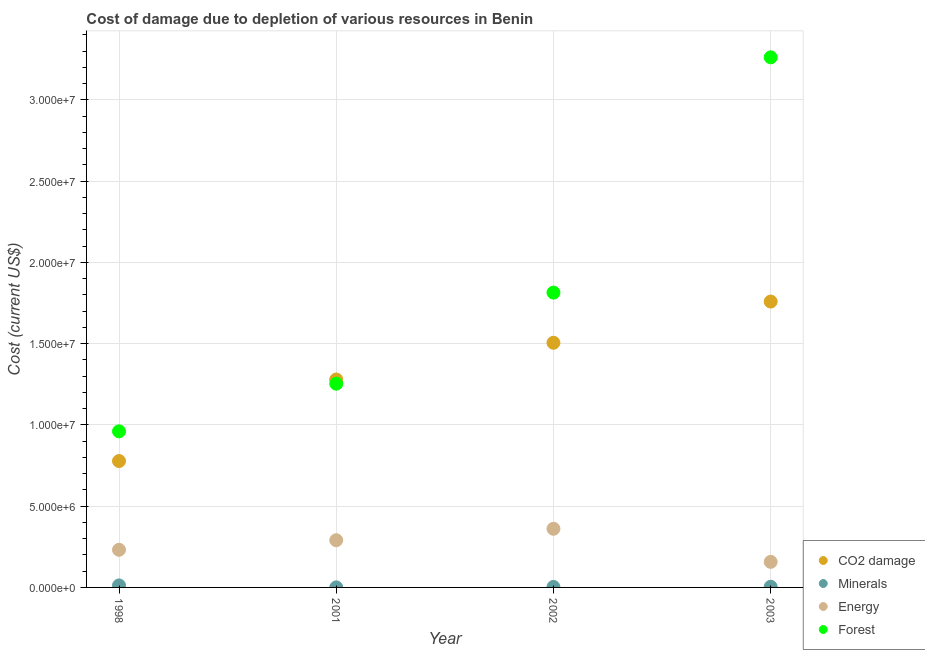How many different coloured dotlines are there?
Make the answer very short. 4. Is the number of dotlines equal to the number of legend labels?
Offer a terse response. Yes. What is the cost of damage due to depletion of forests in 2001?
Your response must be concise. 1.25e+07. Across all years, what is the maximum cost of damage due to depletion of minerals?
Provide a short and direct response. 1.23e+05. Across all years, what is the minimum cost of damage due to depletion of forests?
Provide a succinct answer. 9.60e+06. In which year was the cost of damage due to depletion of forests maximum?
Provide a succinct answer. 2003. What is the total cost of damage due to depletion of forests in the graph?
Your answer should be very brief. 7.29e+07. What is the difference between the cost of damage due to depletion of forests in 2001 and that in 2002?
Provide a short and direct response. -5.60e+06. What is the difference between the cost of damage due to depletion of energy in 2002 and the cost of damage due to depletion of forests in 1998?
Ensure brevity in your answer.  -5.99e+06. What is the average cost of damage due to depletion of energy per year?
Keep it short and to the point. 2.60e+06. In the year 2003, what is the difference between the cost of damage due to depletion of energy and cost of damage due to depletion of forests?
Offer a terse response. -3.10e+07. What is the ratio of the cost of damage due to depletion of energy in 1998 to that in 2001?
Your answer should be compact. 0.8. Is the cost of damage due to depletion of minerals in 2001 less than that in 2002?
Offer a terse response. Yes. Is the difference between the cost of damage due to depletion of minerals in 1998 and 2001 greater than the difference between the cost of damage due to depletion of coal in 1998 and 2001?
Ensure brevity in your answer.  Yes. What is the difference between the highest and the second highest cost of damage due to depletion of minerals?
Give a very brief answer. 8.37e+04. What is the difference between the highest and the lowest cost of damage due to depletion of forests?
Provide a short and direct response. 2.30e+07. In how many years, is the cost of damage due to depletion of minerals greater than the average cost of damage due to depletion of minerals taken over all years?
Your response must be concise. 1. Is the sum of the cost of damage due to depletion of forests in 2001 and 2003 greater than the maximum cost of damage due to depletion of energy across all years?
Offer a terse response. Yes. Is the cost of damage due to depletion of minerals strictly greater than the cost of damage due to depletion of forests over the years?
Give a very brief answer. No. How many dotlines are there?
Provide a short and direct response. 4. How many years are there in the graph?
Keep it short and to the point. 4. Are the values on the major ticks of Y-axis written in scientific E-notation?
Ensure brevity in your answer.  Yes. How many legend labels are there?
Keep it short and to the point. 4. What is the title of the graph?
Ensure brevity in your answer.  Cost of damage due to depletion of various resources in Benin . What is the label or title of the X-axis?
Keep it short and to the point. Year. What is the label or title of the Y-axis?
Offer a very short reply. Cost (current US$). What is the Cost (current US$) of CO2 damage in 1998?
Ensure brevity in your answer.  7.78e+06. What is the Cost (current US$) in Minerals in 1998?
Keep it short and to the point. 1.23e+05. What is the Cost (current US$) of Energy in 1998?
Make the answer very short. 2.32e+06. What is the Cost (current US$) in Forest in 1998?
Offer a very short reply. 9.60e+06. What is the Cost (current US$) in CO2 damage in 2001?
Give a very brief answer. 1.28e+07. What is the Cost (current US$) of Minerals in 2001?
Make the answer very short. 2027.69. What is the Cost (current US$) of Energy in 2001?
Provide a short and direct response. 2.90e+06. What is the Cost (current US$) in Forest in 2001?
Give a very brief answer. 1.25e+07. What is the Cost (current US$) of CO2 damage in 2002?
Offer a terse response. 1.51e+07. What is the Cost (current US$) of Minerals in 2002?
Give a very brief answer. 2.96e+04. What is the Cost (current US$) of Energy in 2002?
Offer a terse response. 3.61e+06. What is the Cost (current US$) of Forest in 2002?
Offer a very short reply. 1.81e+07. What is the Cost (current US$) in CO2 damage in 2003?
Keep it short and to the point. 1.76e+07. What is the Cost (current US$) in Minerals in 2003?
Your answer should be compact. 3.92e+04. What is the Cost (current US$) in Energy in 2003?
Your answer should be compact. 1.57e+06. What is the Cost (current US$) in Forest in 2003?
Offer a very short reply. 3.26e+07. Across all years, what is the maximum Cost (current US$) of CO2 damage?
Provide a succinct answer. 1.76e+07. Across all years, what is the maximum Cost (current US$) of Minerals?
Give a very brief answer. 1.23e+05. Across all years, what is the maximum Cost (current US$) in Energy?
Ensure brevity in your answer.  3.61e+06. Across all years, what is the maximum Cost (current US$) in Forest?
Provide a succinct answer. 3.26e+07. Across all years, what is the minimum Cost (current US$) of CO2 damage?
Ensure brevity in your answer.  7.78e+06. Across all years, what is the minimum Cost (current US$) of Minerals?
Your answer should be compact. 2027.69. Across all years, what is the minimum Cost (current US$) in Energy?
Your answer should be compact. 1.57e+06. Across all years, what is the minimum Cost (current US$) of Forest?
Provide a short and direct response. 9.60e+06. What is the total Cost (current US$) of CO2 damage in the graph?
Provide a succinct answer. 5.32e+07. What is the total Cost (current US$) of Minerals in the graph?
Your answer should be very brief. 1.94e+05. What is the total Cost (current US$) in Energy in the graph?
Keep it short and to the point. 1.04e+07. What is the total Cost (current US$) of Forest in the graph?
Offer a very short reply. 7.29e+07. What is the difference between the Cost (current US$) in CO2 damage in 1998 and that in 2001?
Your answer should be compact. -5.02e+06. What is the difference between the Cost (current US$) in Minerals in 1998 and that in 2001?
Keep it short and to the point. 1.21e+05. What is the difference between the Cost (current US$) of Energy in 1998 and that in 2001?
Provide a short and direct response. -5.87e+05. What is the difference between the Cost (current US$) of Forest in 1998 and that in 2001?
Ensure brevity in your answer.  -2.93e+06. What is the difference between the Cost (current US$) in CO2 damage in 1998 and that in 2002?
Keep it short and to the point. -7.28e+06. What is the difference between the Cost (current US$) of Minerals in 1998 and that in 2002?
Keep it short and to the point. 9.33e+04. What is the difference between the Cost (current US$) of Energy in 1998 and that in 2002?
Keep it short and to the point. -1.29e+06. What is the difference between the Cost (current US$) in Forest in 1998 and that in 2002?
Keep it short and to the point. -8.54e+06. What is the difference between the Cost (current US$) in CO2 damage in 1998 and that in 2003?
Your response must be concise. -9.81e+06. What is the difference between the Cost (current US$) in Minerals in 1998 and that in 2003?
Your response must be concise. 8.37e+04. What is the difference between the Cost (current US$) in Energy in 1998 and that in 2003?
Your response must be concise. 7.44e+05. What is the difference between the Cost (current US$) in Forest in 1998 and that in 2003?
Your answer should be very brief. -2.30e+07. What is the difference between the Cost (current US$) of CO2 damage in 2001 and that in 2002?
Make the answer very short. -2.26e+06. What is the difference between the Cost (current US$) of Minerals in 2001 and that in 2002?
Give a very brief answer. -2.76e+04. What is the difference between the Cost (current US$) of Energy in 2001 and that in 2002?
Give a very brief answer. -7.04e+05. What is the difference between the Cost (current US$) of Forest in 2001 and that in 2002?
Offer a very short reply. -5.60e+06. What is the difference between the Cost (current US$) in CO2 damage in 2001 and that in 2003?
Ensure brevity in your answer.  -4.80e+06. What is the difference between the Cost (current US$) in Minerals in 2001 and that in 2003?
Your response must be concise. -3.72e+04. What is the difference between the Cost (current US$) of Energy in 2001 and that in 2003?
Provide a succinct answer. 1.33e+06. What is the difference between the Cost (current US$) of Forest in 2001 and that in 2003?
Ensure brevity in your answer.  -2.01e+07. What is the difference between the Cost (current US$) of CO2 damage in 2002 and that in 2003?
Give a very brief answer. -2.54e+06. What is the difference between the Cost (current US$) in Minerals in 2002 and that in 2003?
Provide a short and direct response. -9606.34. What is the difference between the Cost (current US$) of Energy in 2002 and that in 2003?
Provide a short and direct response. 2.04e+06. What is the difference between the Cost (current US$) in Forest in 2002 and that in 2003?
Make the answer very short. -1.45e+07. What is the difference between the Cost (current US$) of CO2 damage in 1998 and the Cost (current US$) of Minerals in 2001?
Keep it short and to the point. 7.78e+06. What is the difference between the Cost (current US$) of CO2 damage in 1998 and the Cost (current US$) of Energy in 2001?
Your answer should be very brief. 4.87e+06. What is the difference between the Cost (current US$) of CO2 damage in 1998 and the Cost (current US$) of Forest in 2001?
Give a very brief answer. -4.76e+06. What is the difference between the Cost (current US$) in Minerals in 1998 and the Cost (current US$) in Energy in 2001?
Offer a very short reply. -2.78e+06. What is the difference between the Cost (current US$) in Minerals in 1998 and the Cost (current US$) in Forest in 2001?
Make the answer very short. -1.24e+07. What is the difference between the Cost (current US$) of Energy in 1998 and the Cost (current US$) of Forest in 2001?
Provide a succinct answer. -1.02e+07. What is the difference between the Cost (current US$) of CO2 damage in 1998 and the Cost (current US$) of Minerals in 2002?
Your response must be concise. 7.75e+06. What is the difference between the Cost (current US$) in CO2 damage in 1998 and the Cost (current US$) in Energy in 2002?
Your response must be concise. 4.17e+06. What is the difference between the Cost (current US$) in CO2 damage in 1998 and the Cost (current US$) in Forest in 2002?
Keep it short and to the point. -1.04e+07. What is the difference between the Cost (current US$) of Minerals in 1998 and the Cost (current US$) of Energy in 2002?
Your response must be concise. -3.49e+06. What is the difference between the Cost (current US$) in Minerals in 1998 and the Cost (current US$) in Forest in 2002?
Your answer should be compact. -1.80e+07. What is the difference between the Cost (current US$) of Energy in 1998 and the Cost (current US$) of Forest in 2002?
Offer a very short reply. -1.58e+07. What is the difference between the Cost (current US$) of CO2 damage in 1998 and the Cost (current US$) of Minerals in 2003?
Your answer should be very brief. 7.74e+06. What is the difference between the Cost (current US$) of CO2 damage in 1998 and the Cost (current US$) of Energy in 2003?
Provide a short and direct response. 6.20e+06. What is the difference between the Cost (current US$) in CO2 damage in 1998 and the Cost (current US$) in Forest in 2003?
Provide a short and direct response. -2.48e+07. What is the difference between the Cost (current US$) in Minerals in 1998 and the Cost (current US$) in Energy in 2003?
Give a very brief answer. -1.45e+06. What is the difference between the Cost (current US$) in Minerals in 1998 and the Cost (current US$) in Forest in 2003?
Your response must be concise. -3.25e+07. What is the difference between the Cost (current US$) of Energy in 1998 and the Cost (current US$) of Forest in 2003?
Give a very brief answer. -3.03e+07. What is the difference between the Cost (current US$) in CO2 damage in 2001 and the Cost (current US$) in Minerals in 2002?
Provide a succinct answer. 1.28e+07. What is the difference between the Cost (current US$) of CO2 damage in 2001 and the Cost (current US$) of Energy in 2002?
Keep it short and to the point. 9.18e+06. What is the difference between the Cost (current US$) in CO2 damage in 2001 and the Cost (current US$) in Forest in 2002?
Provide a short and direct response. -5.35e+06. What is the difference between the Cost (current US$) in Minerals in 2001 and the Cost (current US$) in Energy in 2002?
Offer a terse response. -3.61e+06. What is the difference between the Cost (current US$) in Minerals in 2001 and the Cost (current US$) in Forest in 2002?
Make the answer very short. -1.81e+07. What is the difference between the Cost (current US$) in Energy in 2001 and the Cost (current US$) in Forest in 2002?
Offer a terse response. -1.52e+07. What is the difference between the Cost (current US$) in CO2 damage in 2001 and the Cost (current US$) in Minerals in 2003?
Give a very brief answer. 1.28e+07. What is the difference between the Cost (current US$) in CO2 damage in 2001 and the Cost (current US$) in Energy in 2003?
Make the answer very short. 1.12e+07. What is the difference between the Cost (current US$) of CO2 damage in 2001 and the Cost (current US$) of Forest in 2003?
Your answer should be very brief. -1.98e+07. What is the difference between the Cost (current US$) of Minerals in 2001 and the Cost (current US$) of Energy in 2003?
Keep it short and to the point. -1.57e+06. What is the difference between the Cost (current US$) of Minerals in 2001 and the Cost (current US$) of Forest in 2003?
Offer a very short reply. -3.26e+07. What is the difference between the Cost (current US$) of Energy in 2001 and the Cost (current US$) of Forest in 2003?
Provide a short and direct response. -2.97e+07. What is the difference between the Cost (current US$) of CO2 damage in 2002 and the Cost (current US$) of Minerals in 2003?
Provide a succinct answer. 1.50e+07. What is the difference between the Cost (current US$) of CO2 damage in 2002 and the Cost (current US$) of Energy in 2003?
Make the answer very short. 1.35e+07. What is the difference between the Cost (current US$) in CO2 damage in 2002 and the Cost (current US$) in Forest in 2003?
Offer a very short reply. -1.76e+07. What is the difference between the Cost (current US$) of Minerals in 2002 and the Cost (current US$) of Energy in 2003?
Give a very brief answer. -1.54e+06. What is the difference between the Cost (current US$) in Minerals in 2002 and the Cost (current US$) in Forest in 2003?
Offer a very short reply. -3.26e+07. What is the difference between the Cost (current US$) of Energy in 2002 and the Cost (current US$) of Forest in 2003?
Provide a succinct answer. -2.90e+07. What is the average Cost (current US$) in CO2 damage per year?
Offer a terse response. 1.33e+07. What is the average Cost (current US$) of Minerals per year?
Provide a succinct answer. 4.84e+04. What is the average Cost (current US$) in Energy per year?
Your answer should be very brief. 2.60e+06. What is the average Cost (current US$) in Forest per year?
Give a very brief answer. 1.82e+07. In the year 1998, what is the difference between the Cost (current US$) in CO2 damage and Cost (current US$) in Minerals?
Keep it short and to the point. 7.65e+06. In the year 1998, what is the difference between the Cost (current US$) in CO2 damage and Cost (current US$) in Energy?
Your response must be concise. 5.46e+06. In the year 1998, what is the difference between the Cost (current US$) in CO2 damage and Cost (current US$) in Forest?
Keep it short and to the point. -1.83e+06. In the year 1998, what is the difference between the Cost (current US$) in Minerals and Cost (current US$) in Energy?
Ensure brevity in your answer.  -2.19e+06. In the year 1998, what is the difference between the Cost (current US$) in Minerals and Cost (current US$) in Forest?
Offer a very short reply. -9.48e+06. In the year 1998, what is the difference between the Cost (current US$) of Energy and Cost (current US$) of Forest?
Keep it short and to the point. -7.29e+06. In the year 2001, what is the difference between the Cost (current US$) of CO2 damage and Cost (current US$) of Minerals?
Offer a terse response. 1.28e+07. In the year 2001, what is the difference between the Cost (current US$) in CO2 damage and Cost (current US$) in Energy?
Provide a succinct answer. 9.89e+06. In the year 2001, what is the difference between the Cost (current US$) in CO2 damage and Cost (current US$) in Forest?
Offer a very short reply. 2.57e+05. In the year 2001, what is the difference between the Cost (current US$) in Minerals and Cost (current US$) in Energy?
Offer a very short reply. -2.90e+06. In the year 2001, what is the difference between the Cost (current US$) in Minerals and Cost (current US$) in Forest?
Give a very brief answer. -1.25e+07. In the year 2001, what is the difference between the Cost (current US$) of Energy and Cost (current US$) of Forest?
Ensure brevity in your answer.  -9.63e+06. In the year 2002, what is the difference between the Cost (current US$) of CO2 damage and Cost (current US$) of Minerals?
Offer a very short reply. 1.50e+07. In the year 2002, what is the difference between the Cost (current US$) in CO2 damage and Cost (current US$) in Energy?
Make the answer very short. 1.14e+07. In the year 2002, what is the difference between the Cost (current US$) in CO2 damage and Cost (current US$) in Forest?
Provide a short and direct response. -3.09e+06. In the year 2002, what is the difference between the Cost (current US$) in Minerals and Cost (current US$) in Energy?
Your response must be concise. -3.58e+06. In the year 2002, what is the difference between the Cost (current US$) in Minerals and Cost (current US$) in Forest?
Offer a terse response. -1.81e+07. In the year 2002, what is the difference between the Cost (current US$) in Energy and Cost (current US$) in Forest?
Provide a short and direct response. -1.45e+07. In the year 2003, what is the difference between the Cost (current US$) in CO2 damage and Cost (current US$) in Minerals?
Make the answer very short. 1.75e+07. In the year 2003, what is the difference between the Cost (current US$) in CO2 damage and Cost (current US$) in Energy?
Keep it short and to the point. 1.60e+07. In the year 2003, what is the difference between the Cost (current US$) in CO2 damage and Cost (current US$) in Forest?
Make the answer very short. -1.50e+07. In the year 2003, what is the difference between the Cost (current US$) in Minerals and Cost (current US$) in Energy?
Make the answer very short. -1.53e+06. In the year 2003, what is the difference between the Cost (current US$) in Minerals and Cost (current US$) in Forest?
Provide a short and direct response. -3.26e+07. In the year 2003, what is the difference between the Cost (current US$) in Energy and Cost (current US$) in Forest?
Give a very brief answer. -3.10e+07. What is the ratio of the Cost (current US$) of CO2 damage in 1998 to that in 2001?
Your answer should be very brief. 0.61. What is the ratio of the Cost (current US$) of Minerals in 1998 to that in 2001?
Your response must be concise. 60.59. What is the ratio of the Cost (current US$) of Energy in 1998 to that in 2001?
Ensure brevity in your answer.  0.8. What is the ratio of the Cost (current US$) of Forest in 1998 to that in 2001?
Offer a very short reply. 0.77. What is the ratio of the Cost (current US$) of CO2 damage in 1998 to that in 2002?
Your answer should be compact. 0.52. What is the ratio of the Cost (current US$) of Minerals in 1998 to that in 2002?
Ensure brevity in your answer.  4.15. What is the ratio of the Cost (current US$) in Energy in 1998 to that in 2002?
Provide a succinct answer. 0.64. What is the ratio of the Cost (current US$) of Forest in 1998 to that in 2002?
Your answer should be very brief. 0.53. What is the ratio of the Cost (current US$) in CO2 damage in 1998 to that in 2003?
Your response must be concise. 0.44. What is the ratio of the Cost (current US$) of Minerals in 1998 to that in 2003?
Provide a short and direct response. 3.13. What is the ratio of the Cost (current US$) of Energy in 1998 to that in 2003?
Your response must be concise. 1.47. What is the ratio of the Cost (current US$) of Forest in 1998 to that in 2003?
Provide a succinct answer. 0.29. What is the ratio of the Cost (current US$) of CO2 damage in 2001 to that in 2002?
Your response must be concise. 0.85. What is the ratio of the Cost (current US$) of Minerals in 2001 to that in 2002?
Your response must be concise. 0.07. What is the ratio of the Cost (current US$) in Energy in 2001 to that in 2002?
Your response must be concise. 0.81. What is the ratio of the Cost (current US$) of Forest in 2001 to that in 2002?
Your answer should be compact. 0.69. What is the ratio of the Cost (current US$) in CO2 damage in 2001 to that in 2003?
Your response must be concise. 0.73. What is the ratio of the Cost (current US$) in Minerals in 2001 to that in 2003?
Offer a terse response. 0.05. What is the ratio of the Cost (current US$) in Energy in 2001 to that in 2003?
Offer a terse response. 1.85. What is the ratio of the Cost (current US$) of Forest in 2001 to that in 2003?
Provide a short and direct response. 0.38. What is the ratio of the Cost (current US$) in CO2 damage in 2002 to that in 2003?
Provide a short and direct response. 0.86. What is the ratio of the Cost (current US$) in Minerals in 2002 to that in 2003?
Your answer should be very brief. 0.76. What is the ratio of the Cost (current US$) of Energy in 2002 to that in 2003?
Offer a terse response. 2.29. What is the ratio of the Cost (current US$) of Forest in 2002 to that in 2003?
Your answer should be very brief. 0.56. What is the difference between the highest and the second highest Cost (current US$) of CO2 damage?
Your answer should be very brief. 2.54e+06. What is the difference between the highest and the second highest Cost (current US$) of Minerals?
Offer a terse response. 8.37e+04. What is the difference between the highest and the second highest Cost (current US$) of Energy?
Ensure brevity in your answer.  7.04e+05. What is the difference between the highest and the second highest Cost (current US$) in Forest?
Your response must be concise. 1.45e+07. What is the difference between the highest and the lowest Cost (current US$) in CO2 damage?
Your response must be concise. 9.81e+06. What is the difference between the highest and the lowest Cost (current US$) in Minerals?
Your answer should be very brief. 1.21e+05. What is the difference between the highest and the lowest Cost (current US$) of Energy?
Offer a terse response. 2.04e+06. What is the difference between the highest and the lowest Cost (current US$) in Forest?
Offer a terse response. 2.30e+07. 